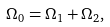Convert formula to latex. <formula><loc_0><loc_0><loc_500><loc_500>\Omega _ { 0 } = \Omega _ { 1 } + \Omega _ { 2 } ,</formula> 